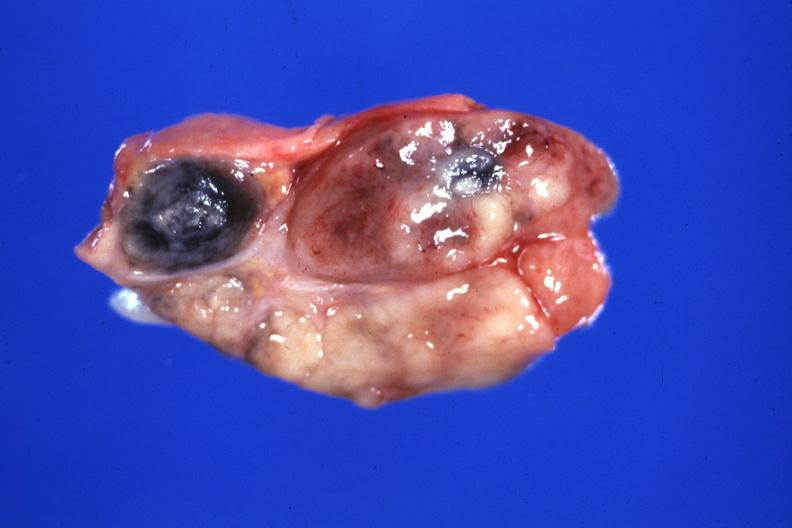s candida present?
Answer the question using a single word or phrase. No 